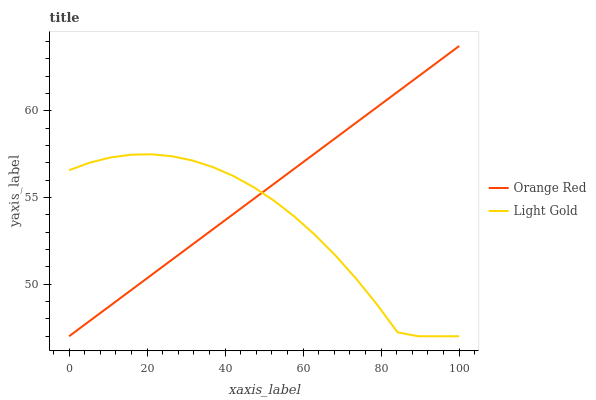Does Light Gold have the minimum area under the curve?
Answer yes or no. Yes. Does Orange Red have the maximum area under the curve?
Answer yes or no. Yes. Does Orange Red have the minimum area under the curve?
Answer yes or no. No. Is Orange Red the smoothest?
Answer yes or no. Yes. Is Light Gold the roughest?
Answer yes or no. Yes. Is Orange Red the roughest?
Answer yes or no. No. 